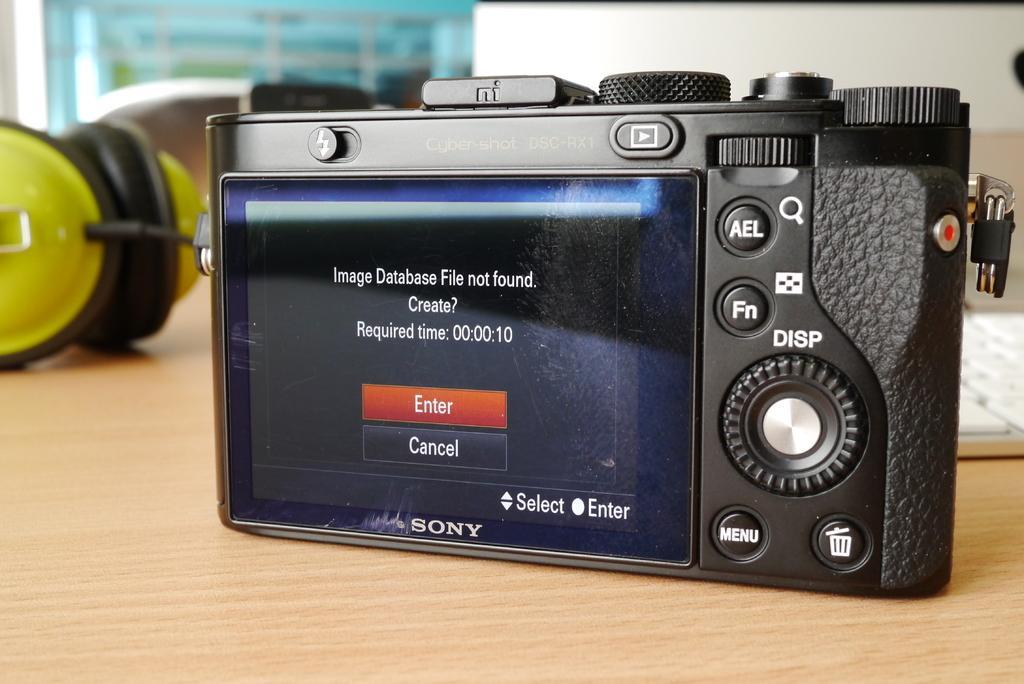Could you give a brief overview of what you see in this image? In this picture we can see a table. On the table we can see a camera, keyboard and object. At the top of the image we can see the wall. 